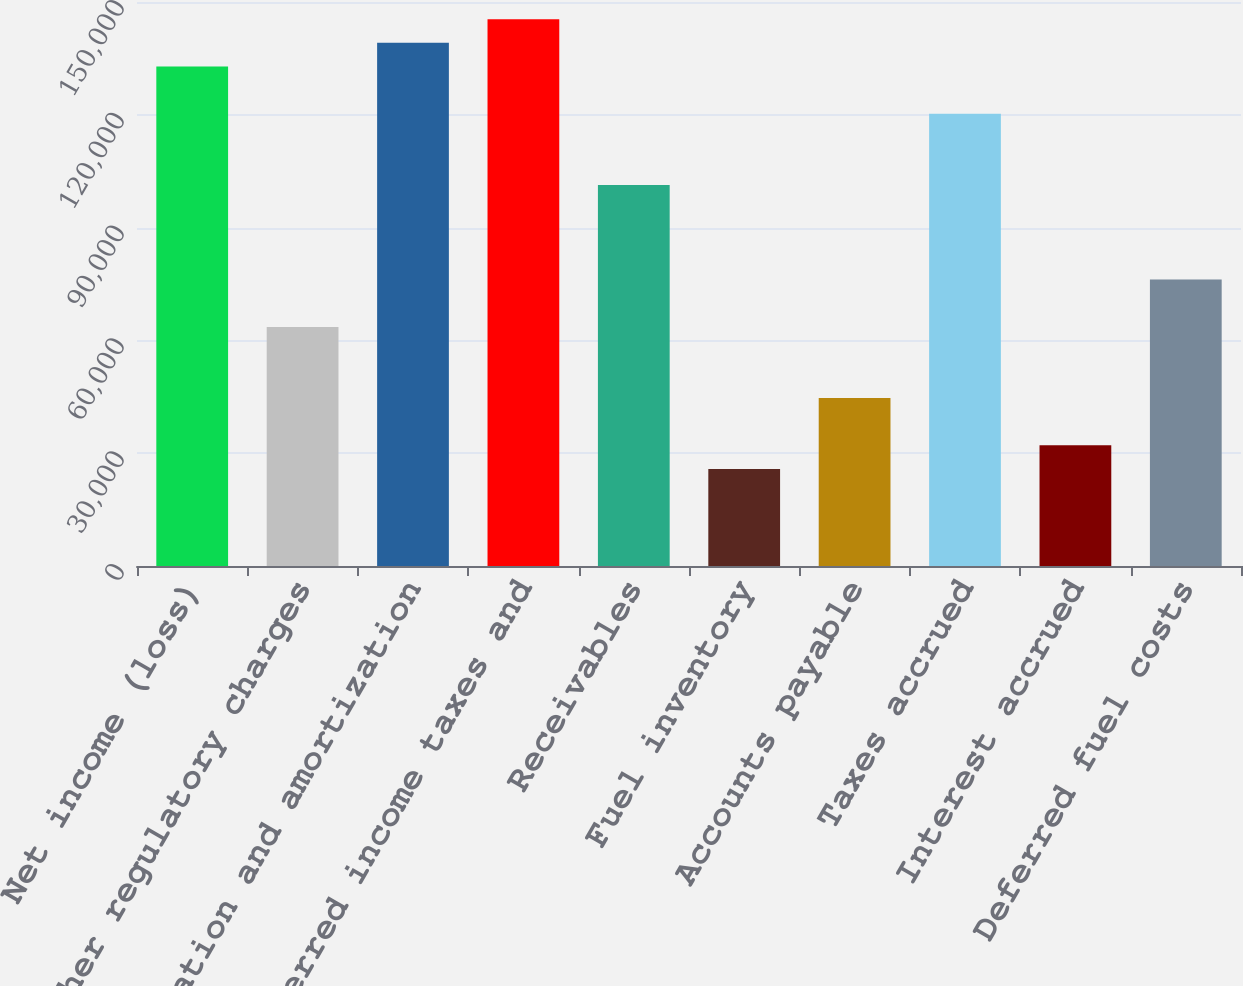Convert chart to OTSL. <chart><loc_0><loc_0><loc_500><loc_500><bar_chart><fcel>Net income (loss)<fcel>Other regulatory charges<fcel>Depreciation and amortization<fcel>Deferred income taxes and<fcel>Receivables<fcel>Fuel inventory<fcel>Accounts payable<fcel>Taxes accrued<fcel>Interest accrued<fcel>Deferred fuel costs<nl><fcel>132845<fcel>63577<fcel>139142<fcel>145439<fcel>101360<fcel>25794.4<fcel>44685.7<fcel>120251<fcel>32091.5<fcel>76171.2<nl></chart> 